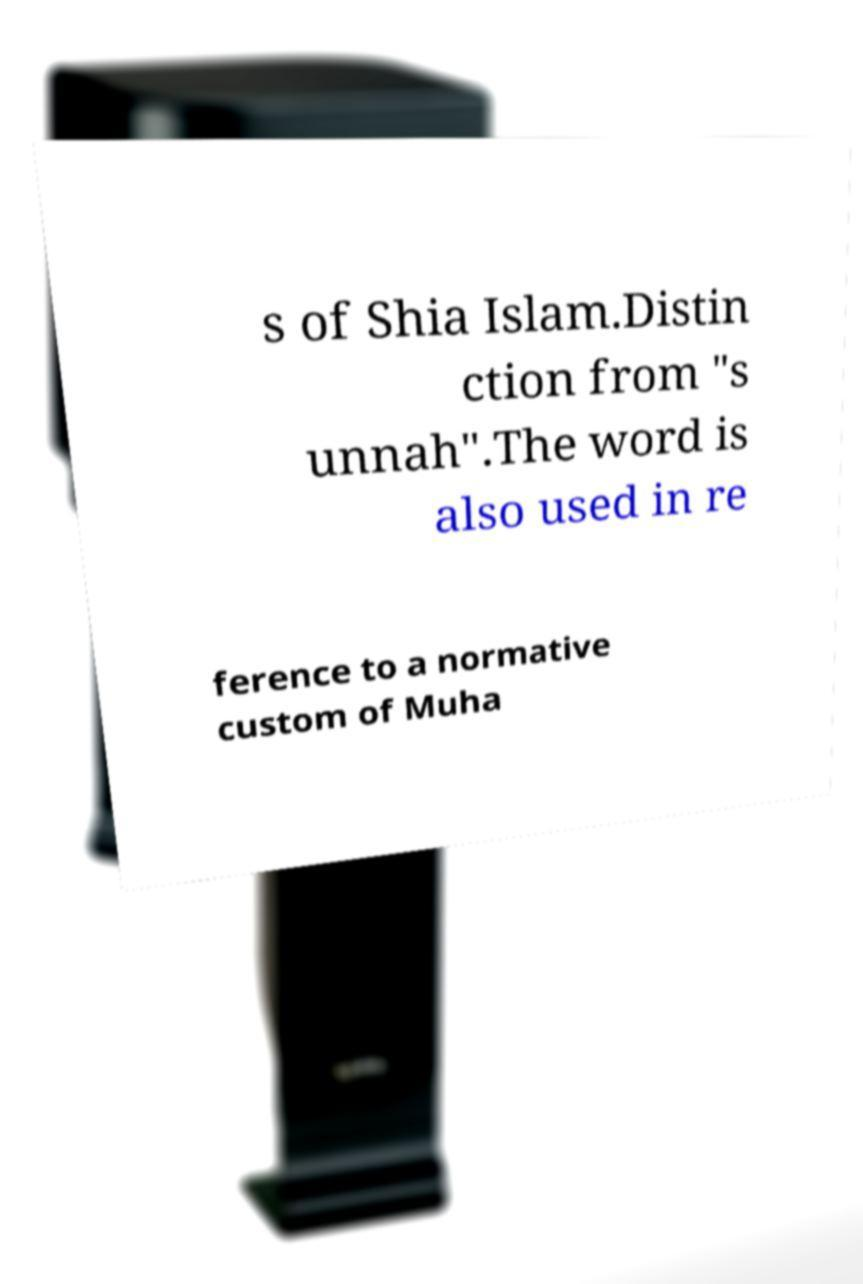Can you accurately transcribe the text from the provided image for me? s of Shia Islam.Distin ction from "s unnah".The word is also used in re ference to a normative custom of Muha 